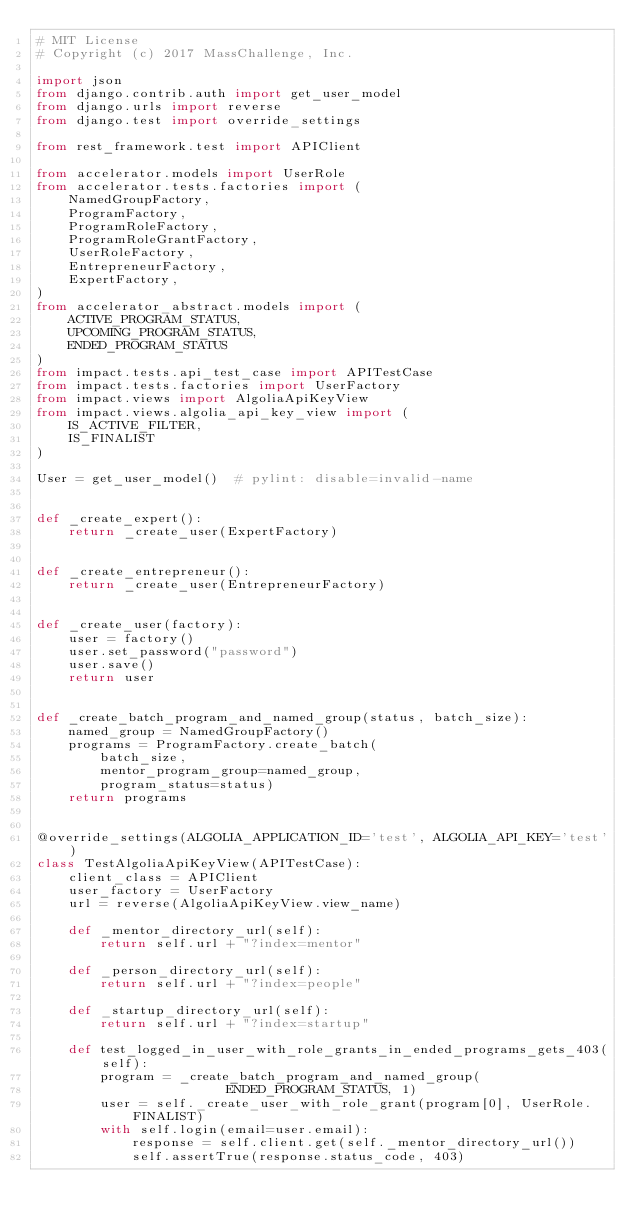Convert code to text. <code><loc_0><loc_0><loc_500><loc_500><_Python_># MIT License
# Copyright (c) 2017 MassChallenge, Inc.

import json
from django.contrib.auth import get_user_model
from django.urls import reverse
from django.test import override_settings

from rest_framework.test import APIClient

from accelerator.models import UserRole
from accelerator.tests.factories import (
    NamedGroupFactory,
    ProgramFactory,
    ProgramRoleFactory,
    ProgramRoleGrantFactory,
    UserRoleFactory,
    EntrepreneurFactory,
    ExpertFactory,
)
from accelerator_abstract.models import (
    ACTIVE_PROGRAM_STATUS,
    UPCOMING_PROGRAM_STATUS,
    ENDED_PROGRAM_STATUS
)
from impact.tests.api_test_case import APITestCase
from impact.tests.factories import UserFactory
from impact.views import AlgoliaApiKeyView
from impact.views.algolia_api_key_view import (
    IS_ACTIVE_FILTER,
    IS_FINALIST
)

User = get_user_model()  # pylint: disable=invalid-name


def _create_expert():
    return _create_user(ExpertFactory)


def _create_entrepreneur():
    return _create_user(EntrepreneurFactory)


def _create_user(factory):
    user = factory()
    user.set_password("password")
    user.save()
    return user


def _create_batch_program_and_named_group(status, batch_size):
    named_group = NamedGroupFactory()
    programs = ProgramFactory.create_batch(
        batch_size,
        mentor_program_group=named_group,
        program_status=status)
    return programs


@override_settings(ALGOLIA_APPLICATION_ID='test', ALGOLIA_API_KEY='test')
class TestAlgoliaApiKeyView(APITestCase):
    client_class = APIClient
    user_factory = UserFactory
    url = reverse(AlgoliaApiKeyView.view_name)

    def _mentor_directory_url(self):
        return self.url + "?index=mentor"

    def _person_directory_url(self):
        return self.url + "?index=people"

    def _startup_directory_url(self):
        return self.url + "?index=startup"

    def test_logged_in_user_with_role_grants_in_ended_programs_gets_403(self):
        program = _create_batch_program_and_named_group(
                        ENDED_PROGRAM_STATUS, 1)
        user = self._create_user_with_role_grant(program[0], UserRole.FINALIST)
        with self.login(email=user.email):
            response = self.client.get(self._mentor_directory_url())
            self.assertTrue(response.status_code, 403)
</code> 